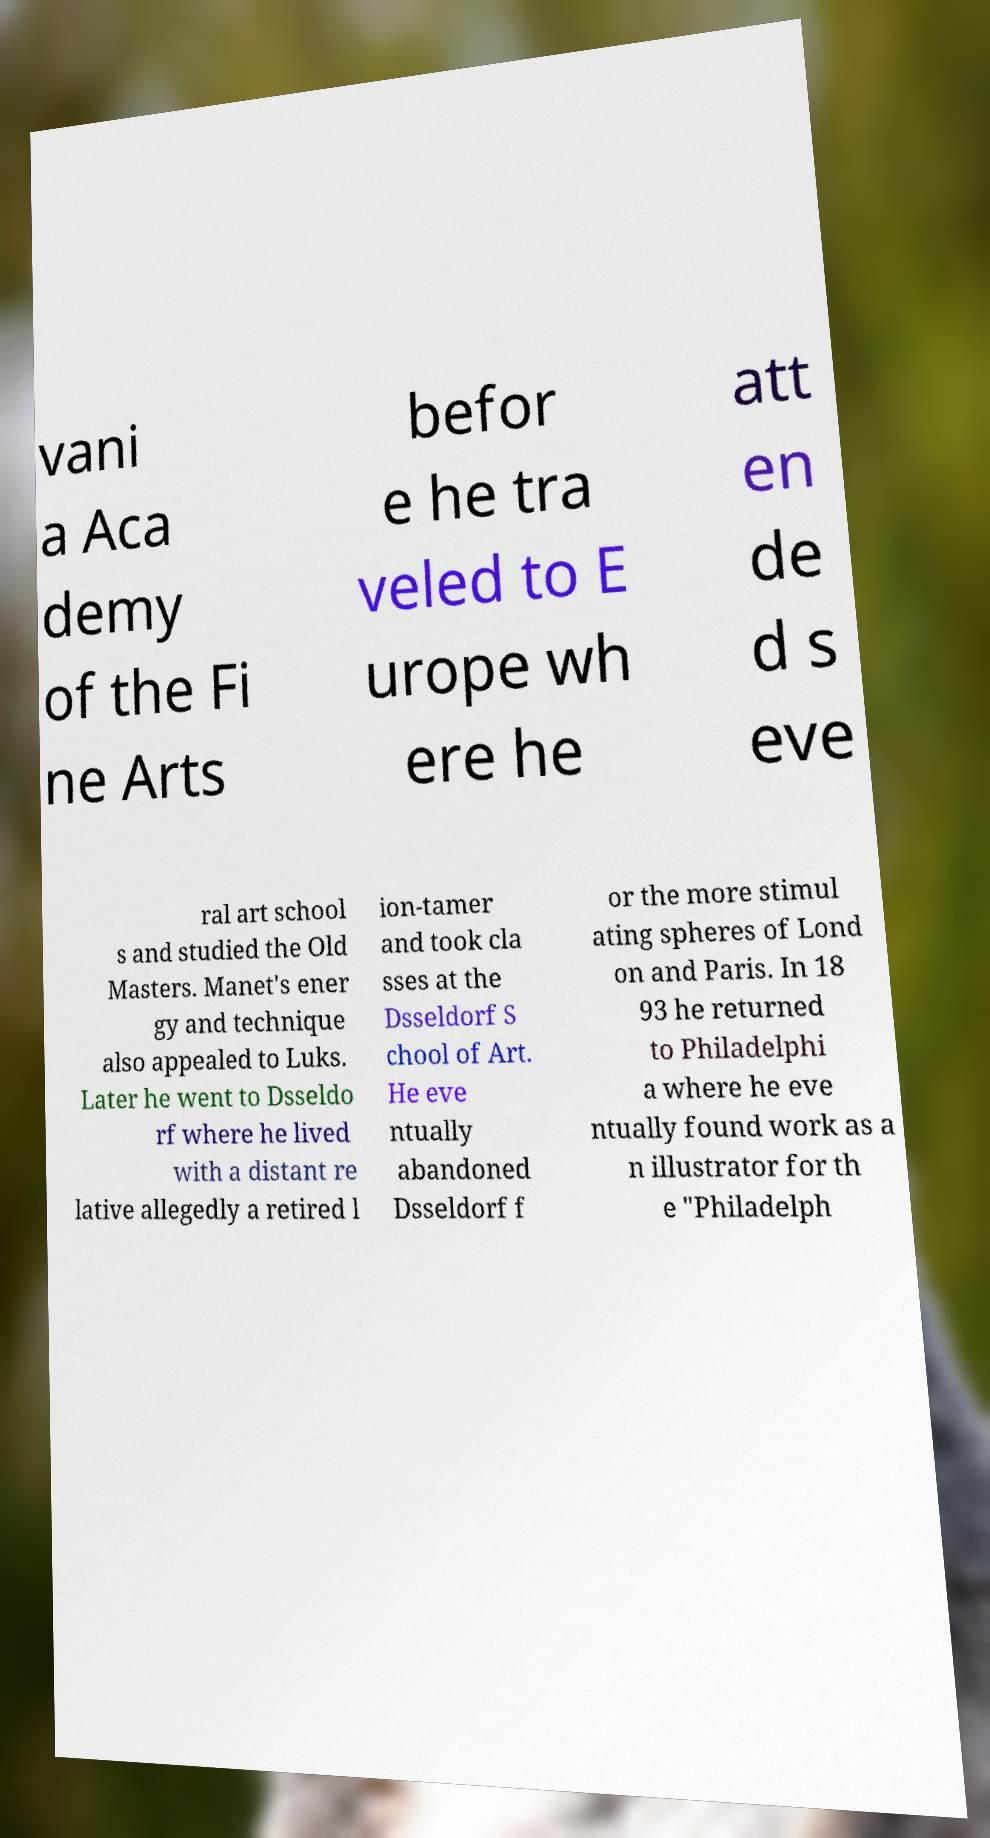Can you accurately transcribe the text from the provided image for me? vani a Aca demy of the Fi ne Arts befor e he tra veled to E urope wh ere he att en de d s eve ral art school s and studied the Old Masters. Manet's ener gy and technique also appealed to Luks. Later he went to Dsseldo rf where he lived with a distant re lative allegedly a retired l ion-tamer and took cla sses at the Dsseldorf S chool of Art. He eve ntually abandoned Dsseldorf f or the more stimul ating spheres of Lond on and Paris. In 18 93 he returned to Philadelphi a where he eve ntually found work as a n illustrator for th e "Philadelph 